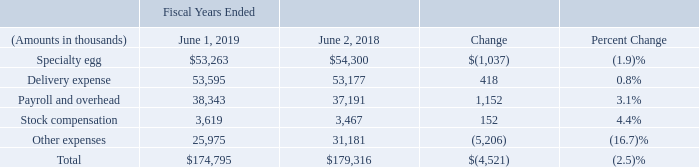SELLING, GENERAL, AND ADMINISTRATIVE EXPENSES
Payroll and overhead increased $1.2 million, or 3.1%, compared to the same period of last year primarily due to annual salary increases. As a percentage of net sales, payroll and overhead is 2.8% and 2.5% for fiscal 2019 and 2018, respectively. As a percentage of net sales, delivery expense is 3.9% and 3.5% for fiscal 2019 and 2018, respectively. Other expenses decreased $5.2 million, or 16.7%, primarily due to reduced legal expense as a result of the Company's settlement of several antitrust claims in the prior year. The fiscal 2018 amount also included costs associated with preparation for the Company's special shareholders meeting held in July 2018. Insurance expense, which is also a part of other expenses, was flat year over year due to decreases in the Company's liability for incurred but not reported claims being offset by overall increases in premiums for fiscal 2019 compared with fiscal 2018. Selling, general and administrative expenses ("SG&A"), which include costs of marketing, distribution, accounting and corporate overhead, were $174.8 million in fiscal 2019, a decrease of $4.5 million, or 2.5%, compared to fiscal 2018. As a percent of net sales, selling, general and administrative expense increased from 11.9% in fiscal 2018 to 12.8% in fiscal 2019, due to the decrease in net sales in fiscal 2019. Selling, general and administrative expenses ("SG&A"), which include costs of marketing, distribution, accounting and corporate overhead, were $174.8 million in fiscal 2019, a decrease of $4.5 million, or 2.5%, compared to fiscal 2018. As a percent of net sales, selling, general and administrative expense increased from 11.9% in fiscal 2018 to 12.8% in fiscal 2019, due to the decrease in net sales in fiscal 2019.
Payroll and overhead increased $1.2 million, or 3.1%, compared to the same period of last year primarily due to annual salary increases. As a percentage of net sales, payroll and overhead is 2.8% and 2.5% for fiscal 2019 and 2018, respectively. As a percentage of net sales, delivery expense is 3.9% and 3.5% for fiscal 2019 and 2018, respectively. Other expenses decreased $5.2 million, or 16.7%, primarily due to reduced legal expense as a result of the Company's settlement of several antitrust claims in the prior year. The fiscal 2018 amount also included costs associated with preparation for the Company's special shareholders meeting held in July 2018. Insurance expense, which is also a part of other expenses, was flat year over year due to decreases in the Company's liability for incurred but not reported claims being offset by overall increases in premiums for fiscal 2019 compared with fiscal 2018. Payroll and overhead increased $1.2 million, or 3.1%, compared to the same period of last year primarily due to annual salary increases. As a percentage of net sales, payroll and overhead is 2.8% and 2.5% for fiscal 2019 and 2018, respectively. As a percentage of net sales, delivery expense is 3.9% and 3.5% for fiscal 2019 and 2018, respectively. Other expenses decreased $5.2 million, or 16.7%, primarily due to reduced legal expense as a result of the Company's settlement of several antitrust claims in the prior year. The fiscal 2018 amount also included costs associated with preparation for the Company's special shareholders meeting held in July 2018. Insurance expense, which is also a part of other expenses, was flat year over year due to decreases in the Company's liability for incurred but not reported claims being offset by overall increases in premiums for fiscal 2019 compared with fiscal 2018. Payroll and overhead increased $1.2 million, or 3.1%, compared to the same period of last year primarily due to annual salary increases. As a percentage of net sales, payroll and overhead is 2.8% and 2.5% for fiscal 2019 and 2018, respectively. As a percentage of net sales, delivery expense is 3.9% and 3.5% for fiscal 2019 and 2018, respectively. Other expenses decreased $5.2 million, or 16.7%, primarily due to reduced legal expense as a result of the Company's settlement of several antitrust claims in the prior year. The fiscal 2018 amount also included costs associated with preparation for the Company's special shareholders meeting held in July 2018. Insurance expense, which is also a part of other expenses, was flat year over year due to decreases in the Company's liability for incurred but not reported claims being offset by overall increases in premiums for fiscal 2019 compared with fiscal 2018.
SG&A expense was $42.3 million for the thirteen weeks ended June 1, 2019, a decrease of $7.4 million, or 14.8%,
compared to $49.7 million for the thirteen weeks ended June 2, 2018. The decrease in specialty egg expense for the
fiscal 2019 fourth quarter is attributable to the timing of advertising and promotions as well as a decrease in specialty
egg dozens sold resulting in decreased franchise expense. Payroll and overhead decreased $526,000, or 5.2%, compared
to the same period of last year due to timing of bonus accruals. Stock compensation expense relates to the amortization
of compensation expense for grants of restricted stock and is dependent on the closing prices of the Company's stock
on the grant dates. The weighted average grant date fair value of our restricted stock awards at June 1, 2019, was
$43.20, a 2.1% increase over the value of $42.30 at June 2, 2018. Other expenses decreased 27.6% from $8.4 million
for the thirteen weeks ended June 2, 2018 to $6.1 million for the same period of fiscal 2019 primarily due to a reduction
in the liability for incurred but not reported insurance claims at June 1, 2019 as well as a reduction in legal expenses.
What is the specialty egg as a percentage of total total selling, general and administrative expenses in 2019?
Answer scale should be: percent. 53,263 / 174,795
Answer: 30.47. What is the percent change of Delivery Expense from 2018 to 2019? 0.8%. What is the rationale for increase / (decrease) in the selling, general and administrative expense as a percentage of net sales? Due to the decrease in net sales in fiscal 2019. What caused the increase in payroll and overhead expenses in 2019? Due to annual salary increase. What is other expenses constitutes as a percentage of total cost in 2019?
answer scale should be: percent. 25,975 / $174,795
Answer: 14.86. What percentage of total cost does stock compensation form a part of?
Answer scale should be: percent. 3,619 / $174,795
Answer: 2.07. 